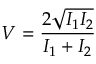Convert formula to latex. <formula><loc_0><loc_0><loc_500><loc_500>V = \frac { 2 \sqrt { I _ { 1 } I _ { 2 } } } { I _ { 1 } + I _ { 2 } }</formula> 